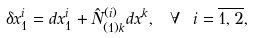<formula> <loc_0><loc_0><loc_500><loc_500>\delta x _ { 1 } ^ { i } = d x _ { 1 } ^ { i } + \hat { N } _ { ( 1 ) k } ^ { ( i ) } d x ^ { k } , \text { } \forall \text { } i = \overline { 1 , 2 } ,</formula> 